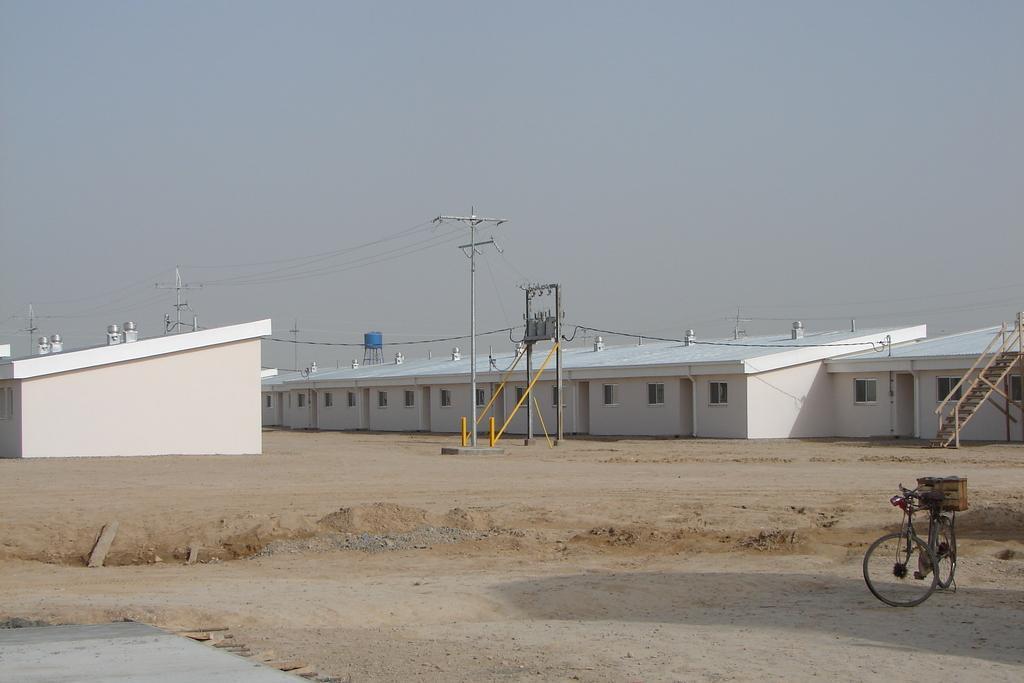Can you describe this image briefly? This is an outside view. On the right side, I can see a bicycle on the ground. In the background there are two buildings and I can see few poles along with the wires. On the right side there are some stairs beside the building. On the top of the image I can see the sky. 